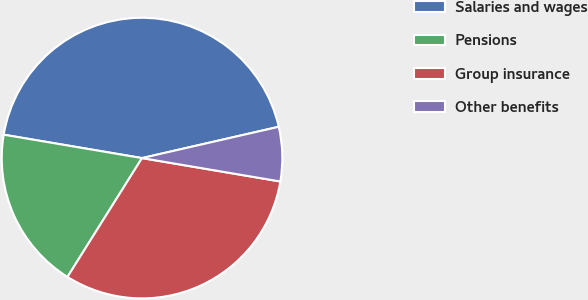<chart> <loc_0><loc_0><loc_500><loc_500><pie_chart><fcel>Salaries and wages<fcel>Pensions<fcel>Group insurance<fcel>Other benefits<nl><fcel>43.75%<fcel>18.75%<fcel>31.25%<fcel>6.25%<nl></chart> 